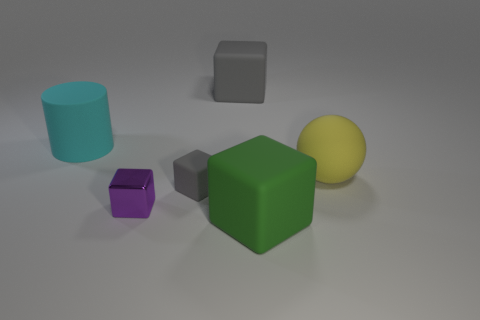Is there any indication about the size or scale of these objects, or anything about their environment? Based on the image alone, absolute size or scale is not determinable as there are no familiar reference objects to compare with. However, relative to each other, objects do vary in size, as seen with the green cube being noticeably larger than the others. The environment appears to be a simple, uncluttered space with diffused lighting, likely designed to keep the focus on the objects themselves. 